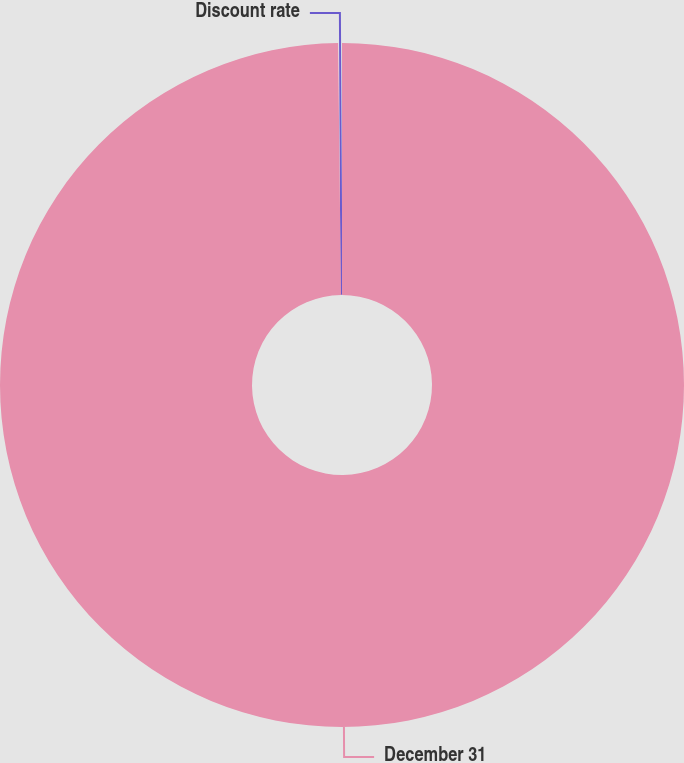Convert chart to OTSL. <chart><loc_0><loc_0><loc_500><loc_500><pie_chart><fcel>December 31<fcel>Discount rate<nl><fcel>99.82%<fcel>0.18%<nl></chart> 